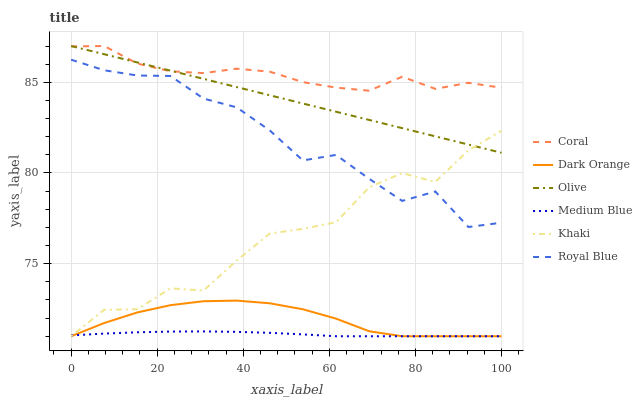Does Medium Blue have the minimum area under the curve?
Answer yes or no. Yes. Does Coral have the maximum area under the curve?
Answer yes or no. Yes. Does Khaki have the minimum area under the curve?
Answer yes or no. No. Does Khaki have the maximum area under the curve?
Answer yes or no. No. Is Olive the smoothest?
Answer yes or no. Yes. Is Khaki the roughest?
Answer yes or no. Yes. Is Coral the smoothest?
Answer yes or no. No. Is Coral the roughest?
Answer yes or no. No. Does Dark Orange have the lowest value?
Answer yes or no. Yes. Does Coral have the lowest value?
Answer yes or no. No. Does Olive have the highest value?
Answer yes or no. Yes. Does Khaki have the highest value?
Answer yes or no. No. Is Dark Orange less than Coral?
Answer yes or no. Yes. Is Royal Blue greater than Medium Blue?
Answer yes or no. Yes. Does Khaki intersect Olive?
Answer yes or no. Yes. Is Khaki less than Olive?
Answer yes or no. No. Is Khaki greater than Olive?
Answer yes or no. No. Does Dark Orange intersect Coral?
Answer yes or no. No. 